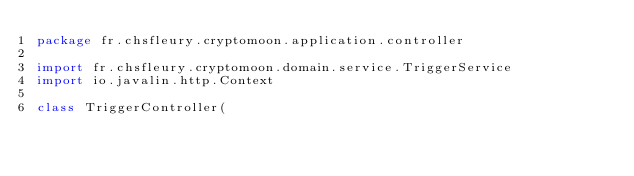<code> <loc_0><loc_0><loc_500><loc_500><_Kotlin_>package fr.chsfleury.cryptomoon.application.controller

import fr.chsfleury.cryptomoon.domain.service.TriggerService
import io.javalin.http.Context

class TriggerController(</code> 